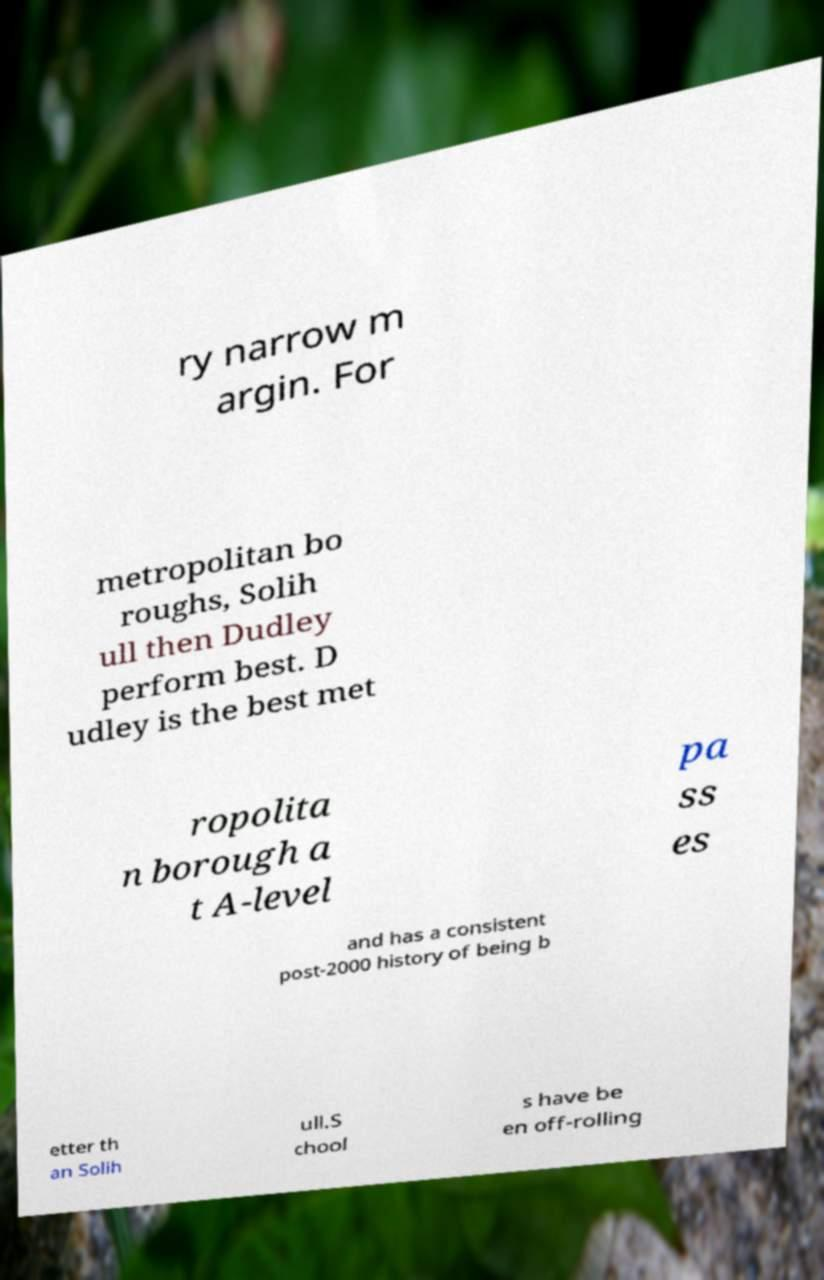I need the written content from this picture converted into text. Can you do that? ry narrow m argin. For metropolitan bo roughs, Solih ull then Dudley perform best. D udley is the best met ropolita n borough a t A-level pa ss es and has a consistent post-2000 history of being b etter th an Solih ull.S chool s have be en off-rolling 